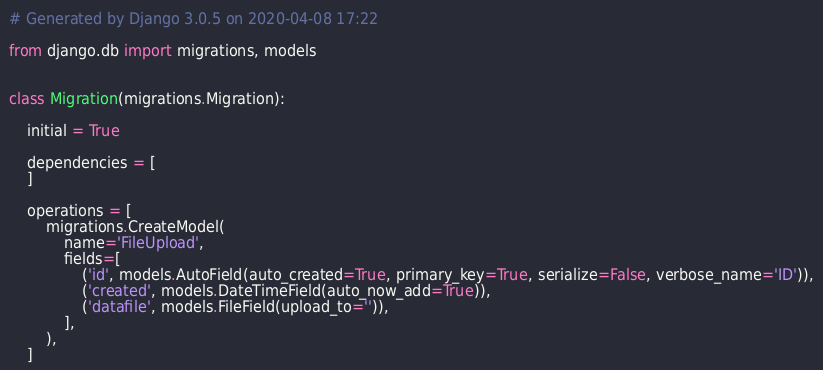Convert code to text. <code><loc_0><loc_0><loc_500><loc_500><_Python_># Generated by Django 3.0.5 on 2020-04-08 17:22

from django.db import migrations, models


class Migration(migrations.Migration):

    initial = True

    dependencies = [
    ]

    operations = [
        migrations.CreateModel(
            name='FileUpload',
            fields=[
                ('id', models.AutoField(auto_created=True, primary_key=True, serialize=False, verbose_name='ID')),
                ('created', models.DateTimeField(auto_now_add=True)),
                ('datafile', models.FileField(upload_to='')),
            ],
        ),
    ]
</code> 